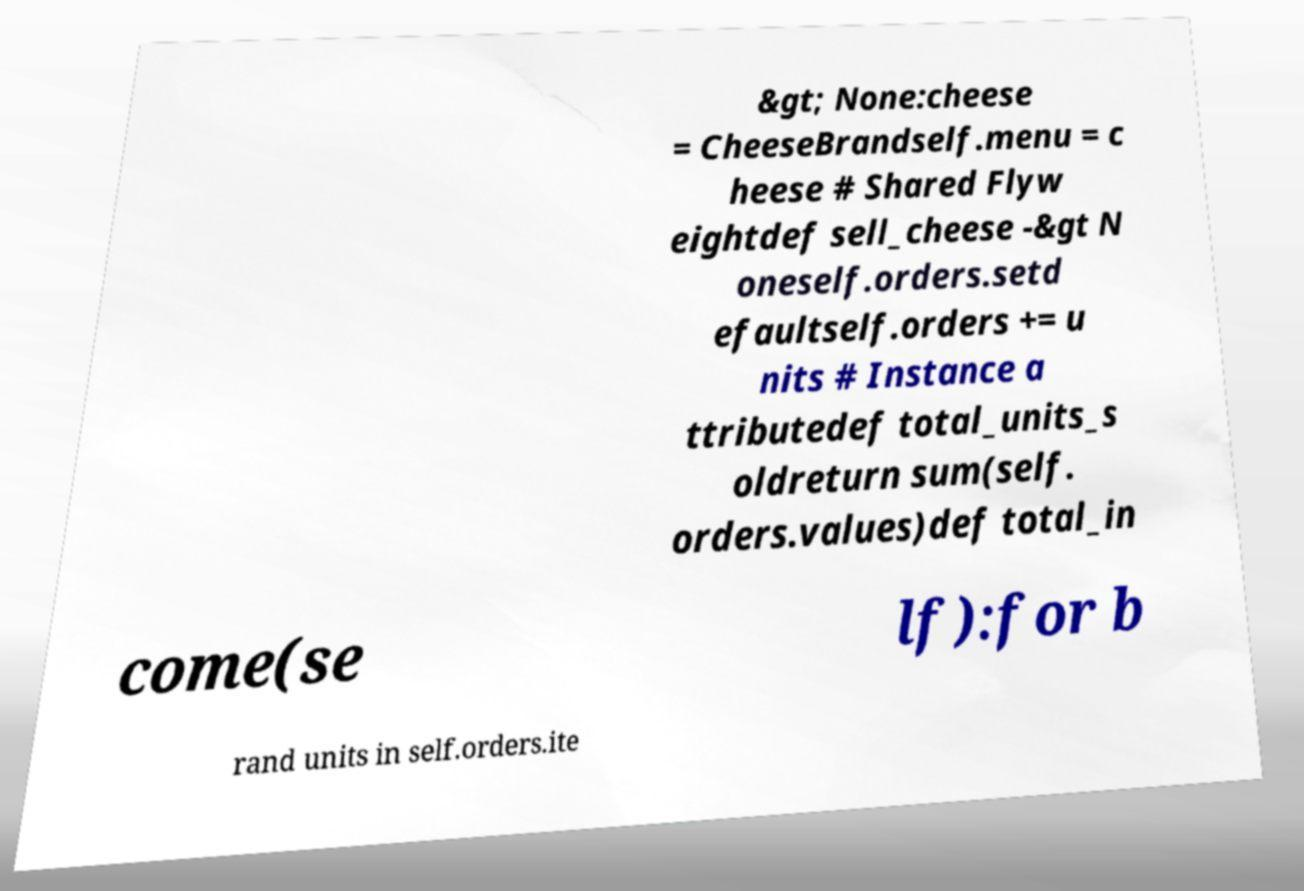Please read and relay the text visible in this image. What does it say? &gt; None:cheese = CheeseBrandself.menu = c heese # Shared Flyw eightdef sell_cheese -&gt N oneself.orders.setd efaultself.orders += u nits # Instance a ttributedef total_units_s oldreturn sum(self. orders.values)def total_in come(se lf):for b rand units in self.orders.ite 